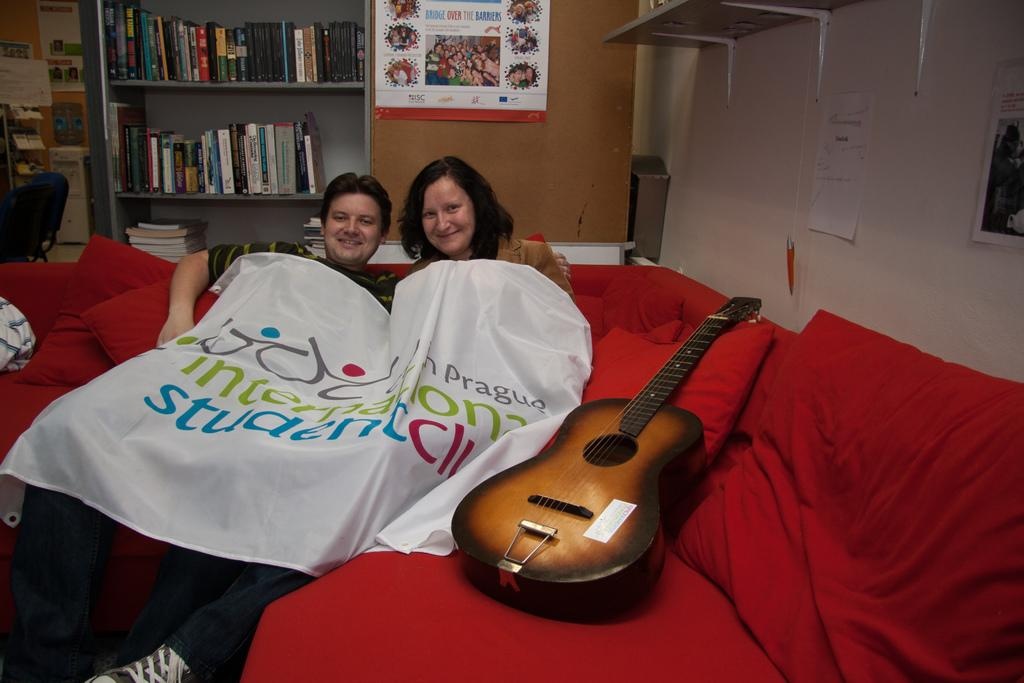How many people are in the image? There are two people in the image, a woman and a man. What are the woman and the man doing in the image? Both the woman and the man are resting on a couch. What object can be seen near the people in the image? There is a guitar in the image. What is covering the couch in the image? A blanket is present in the image. What can be seen on the wall in the background of the image? There is a frame attached to the wall in the background. What type of furniture is present in the background of the image? There is a chair in the background. What can be seen in the background of the image besides the chair? There are books in a rack in the background. How many sisters does the woman in the image have? There is no information about the woman's sisters in the image. What type of roof is visible in the image? There is no roof visible in the image; it is an indoor setting. 